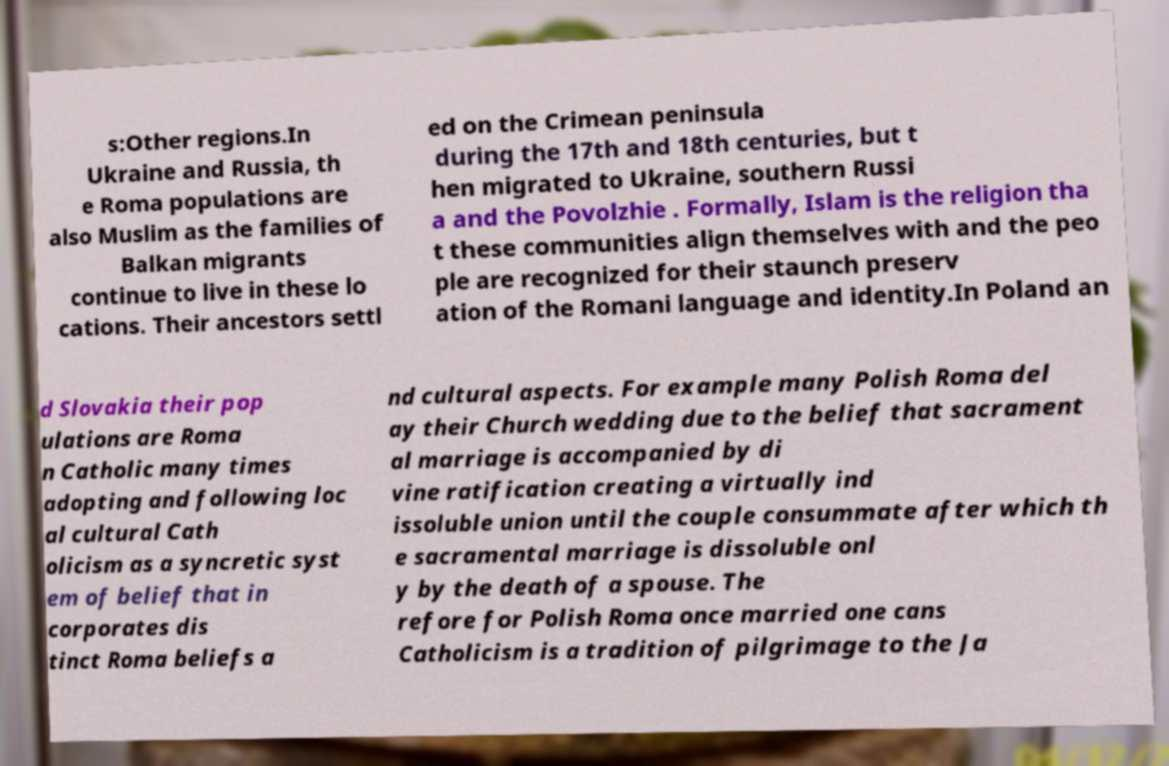There's text embedded in this image that I need extracted. Can you transcribe it verbatim? s:Other regions.In Ukraine and Russia, th e Roma populations are also Muslim as the families of Balkan migrants continue to live in these lo cations. Their ancestors settl ed on the Crimean peninsula during the 17th and 18th centuries, but t hen migrated to Ukraine, southern Russi a and the Povolzhie . Formally, Islam is the religion tha t these communities align themselves with and the peo ple are recognized for their staunch preserv ation of the Romani language and identity.In Poland an d Slovakia their pop ulations are Roma n Catholic many times adopting and following loc al cultural Cath olicism as a syncretic syst em of belief that in corporates dis tinct Roma beliefs a nd cultural aspects. For example many Polish Roma del ay their Church wedding due to the belief that sacrament al marriage is accompanied by di vine ratification creating a virtually ind issoluble union until the couple consummate after which th e sacramental marriage is dissoluble onl y by the death of a spouse. The refore for Polish Roma once married one cans Catholicism is a tradition of pilgrimage to the Ja 